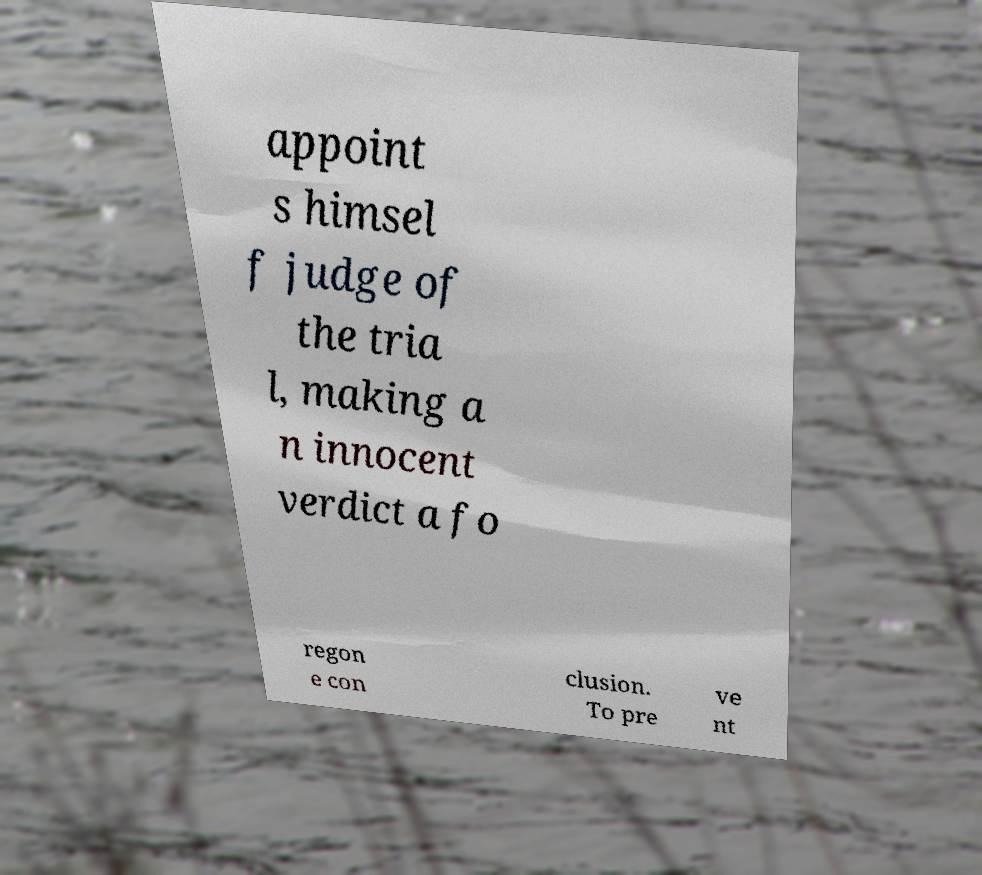What messages or text are displayed in this image? I need them in a readable, typed format. appoint s himsel f judge of the tria l, making a n innocent verdict a fo regon e con clusion. To pre ve nt 